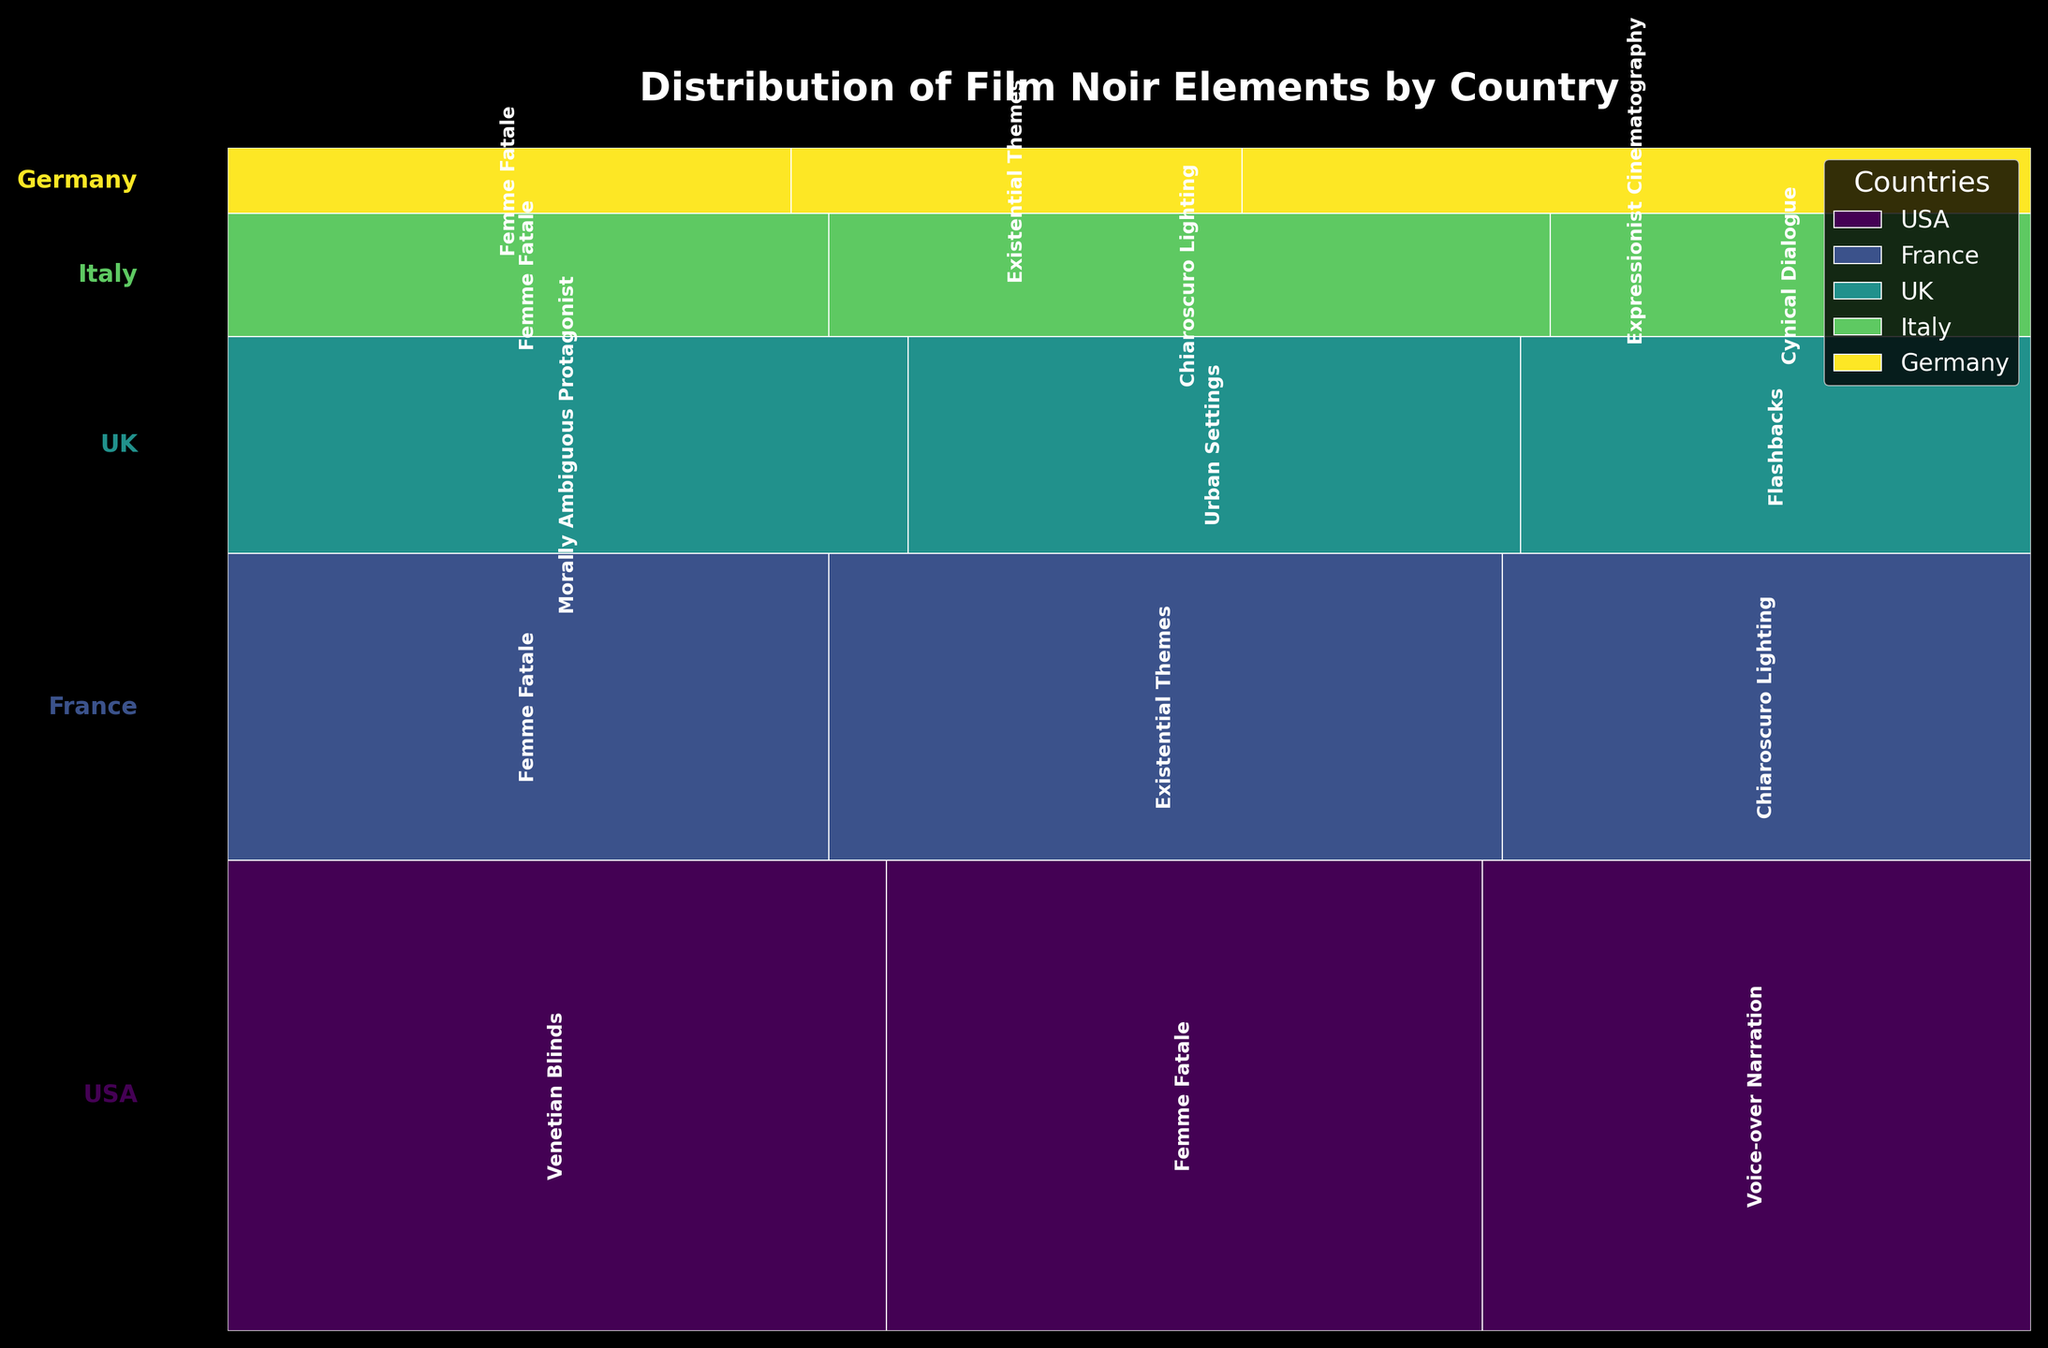What's the title of the plot? The title of a plot is usually placed near the top and is meant to provide a brief summary of what the plot is about. Here, the title should describe the content and context of the mosaic plot.
Answer: Distribution of Film Noir Elements by Country Which country has the highest representation of 'Femme Fatale'? From the plot, you can visually compare the height of segments corresponding to 'Femme Fatale' across different countries. The taller the segment, the higher the count. The USA has the tallest segment for 'Femme Fatale'.
Answer: USA Which film noir element is most common in French films? Check each segment's label under the France country segment and compare their widths within the French section. The widest segment in France corresponds to the most common element.
Answer: Existential Themes What film noir element is shared by all countries in the plot? By scanning each country’s segment, identify the elements that appear across all countries.
Answer: Femme Fatale How does the representation of 'Chiaroscuro Lighting' compare between Italy and France? Observe the 'Chiaroscuro Lighting' segments for both Italy and France by comparing their widths. France has a wider segment, meaning a higher count than Italy.
Answer: France has a higher representation Are there any film noir elements exclusive to one country in the plot? Examine the elements listed under each country. Look for any elements that are only mentioned for one specific country and not for others.
Answer: Yes, 'Cynical Dialogue' is exclusive to Italy and 'Expressionist Cinematography' is exclusive to Germany In which country is 'Flashbacks' represented, and how many times? Look for the 'Flashbacks' element among the countries listed and identify its count from the country segment. ‘Flashbacks’ is shown under the UK segment.
Answer: UK, 15 